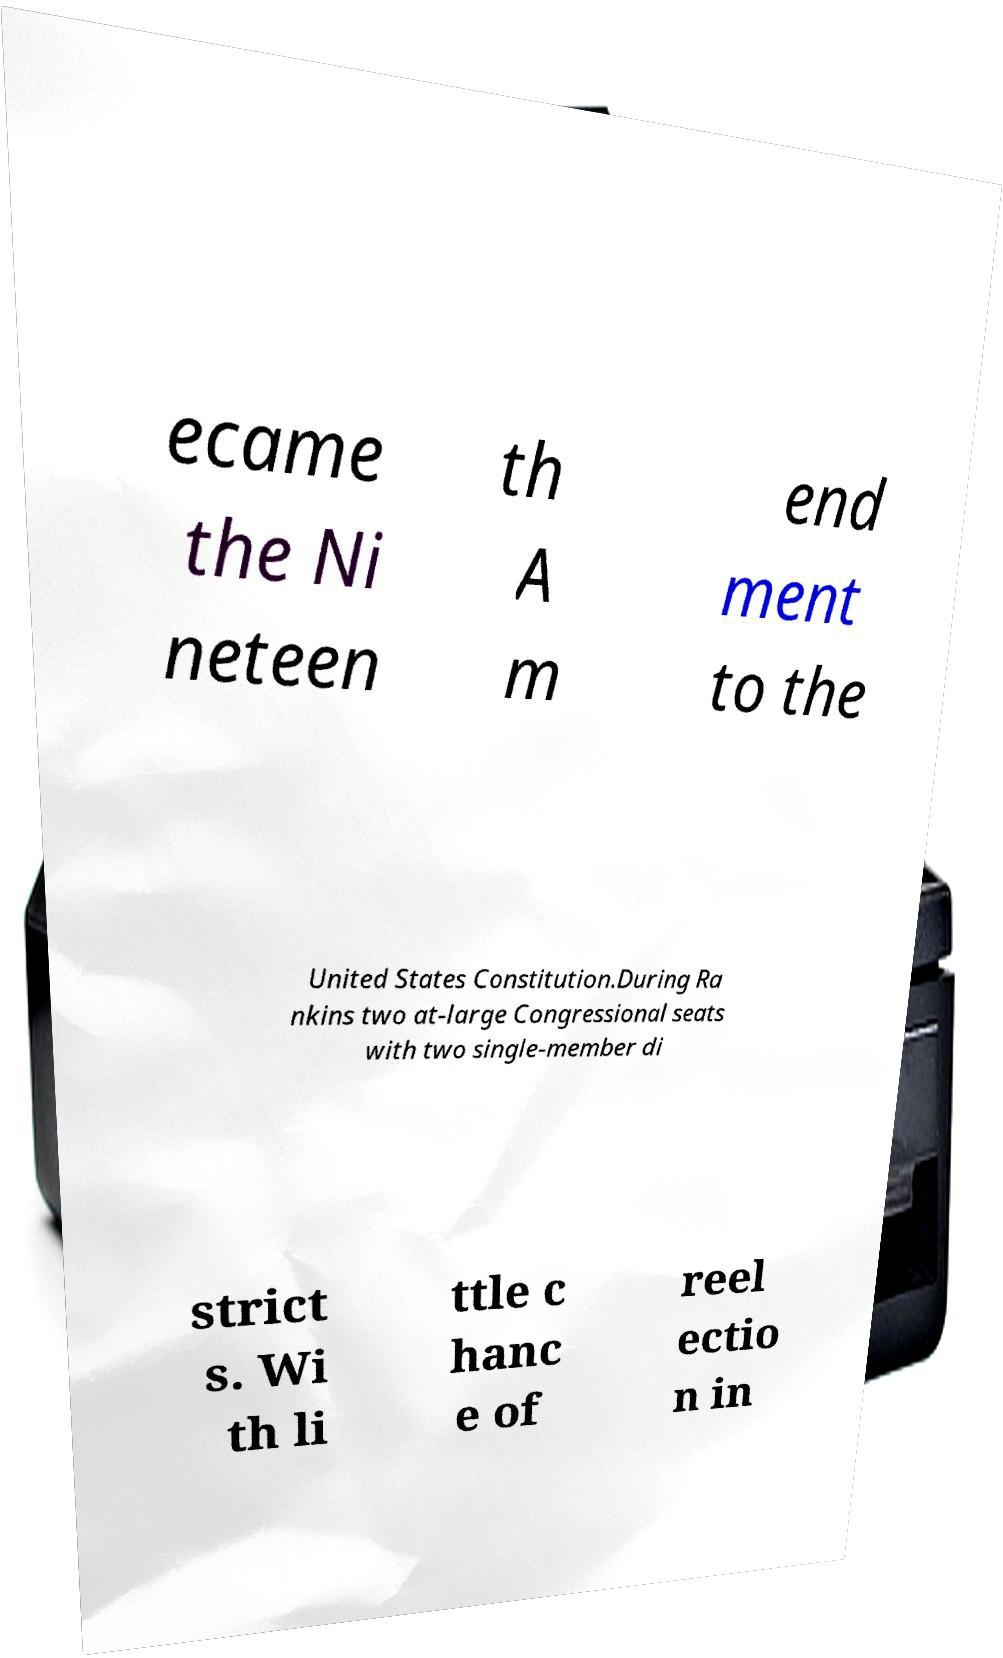Please read and relay the text visible in this image. What does it say? ecame the Ni neteen th A m end ment to the United States Constitution.During Ra nkins two at-large Congressional seats with two single-member di strict s. Wi th li ttle c hanc e of reel ectio n in 